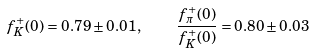<formula> <loc_0><loc_0><loc_500><loc_500>f ^ { + } _ { K } ( 0 ) = 0 . 7 9 \pm 0 . 0 1 , \quad \frac { f ^ { + } _ { \pi } ( 0 ) } { f ^ { + } _ { K } ( 0 ) } = 0 . 8 0 \pm 0 . 0 3</formula> 